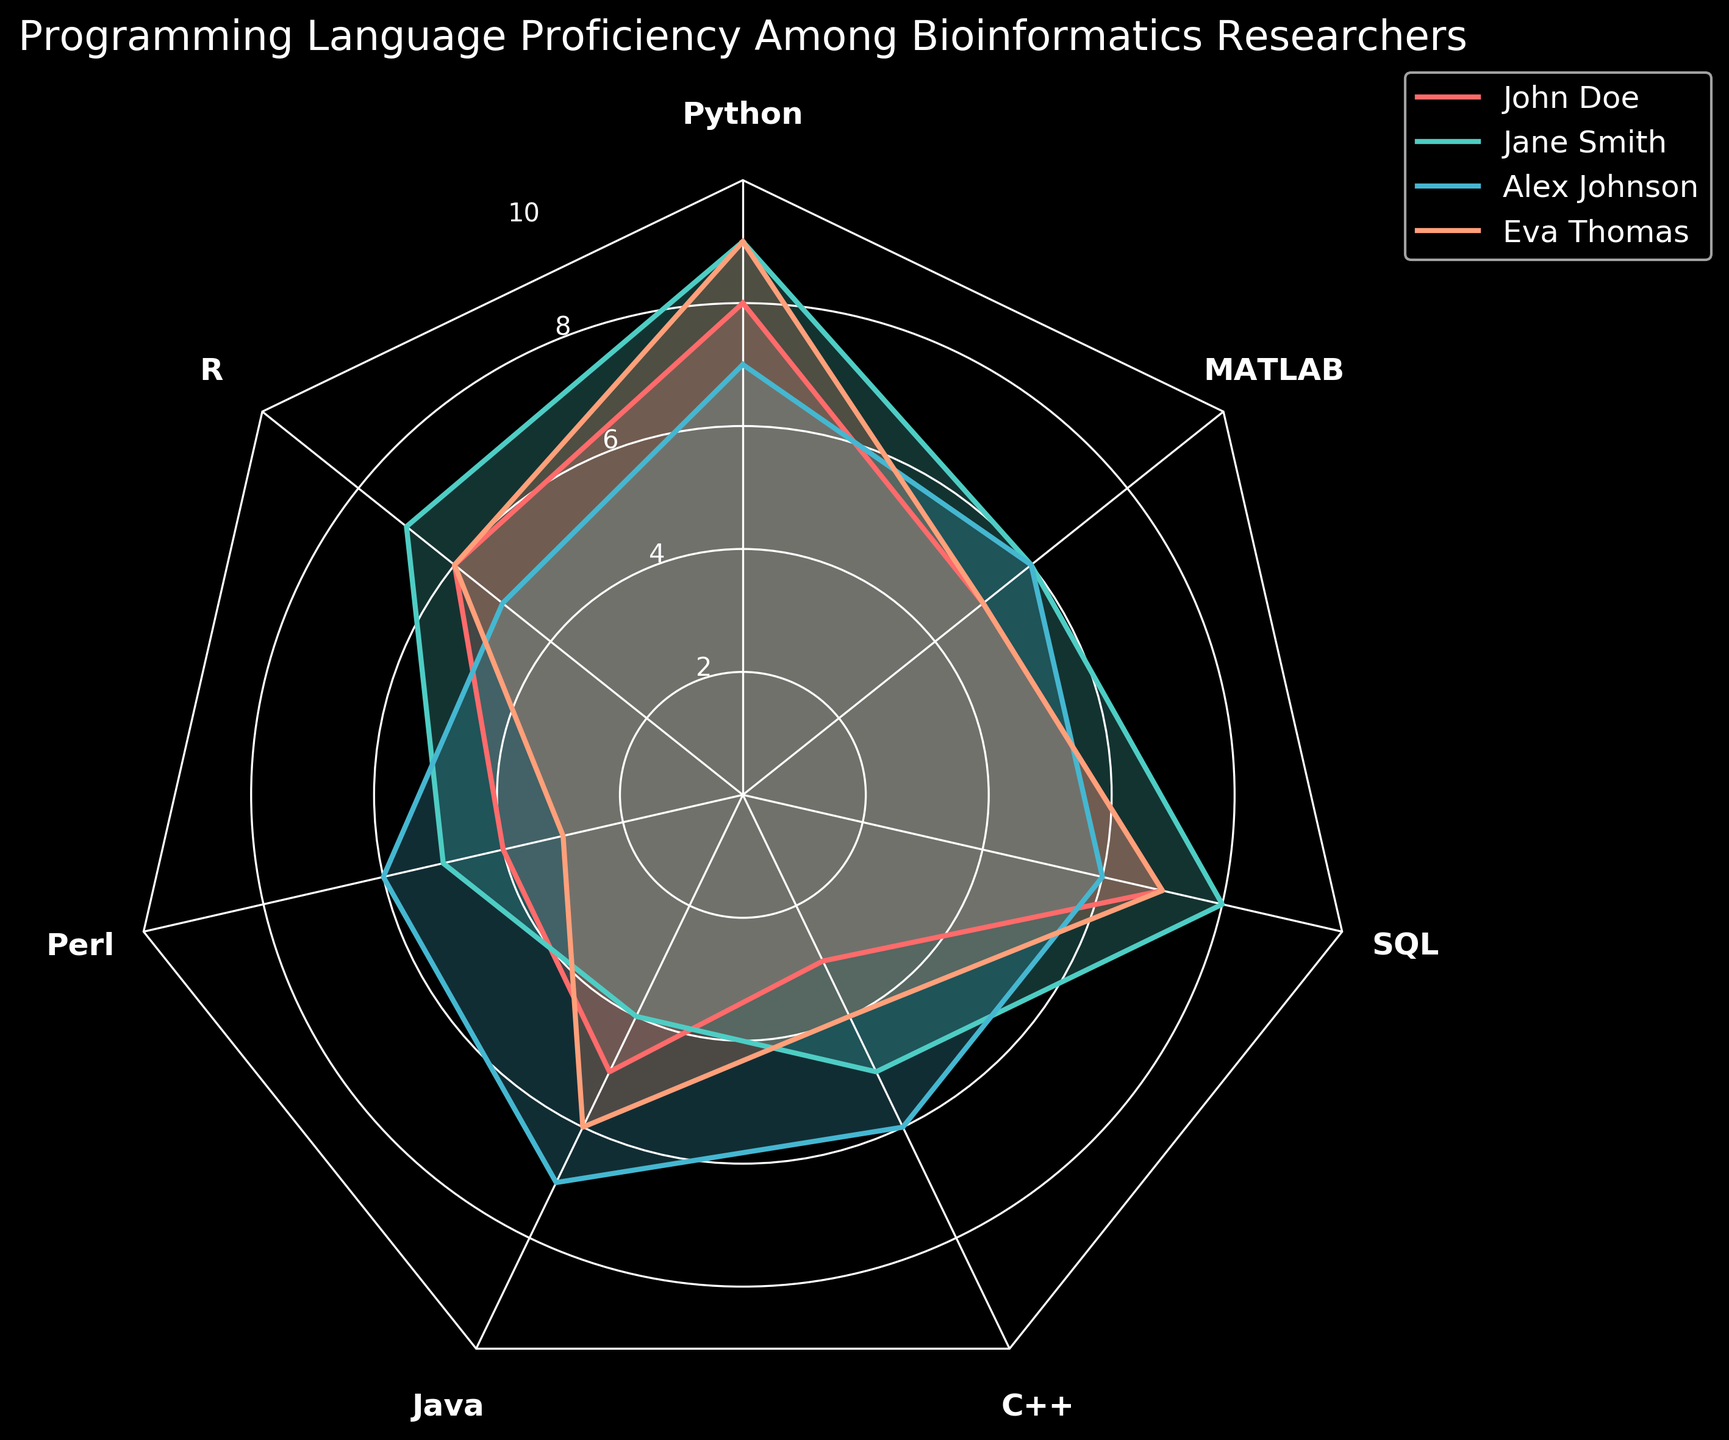What is the title of the radar chart? The title is written at the top of the figure, generally larger and bolder than other texts. It provides an overview of what the chart represents.
Answer: Programming Language Proficiency Among Bioinformatics Researchers Which researcher shows the highest proficiency in Python? Look at the points plotted for Python for each researcher and identify the highest value, which is represented by the most extended line on the radar chart among the values for Python.
Answer: Jane Smith How many programming languages are included in the chart? Count the number of labeled spokes in the radar chart, each representing a different programming language.
Answer: Seven Which programming language does Alex Johnson have the highest proficiency in? Identify the maximum value for Alex Johnson across all programming languages by looking for the most extended plot line for Alex Johnson.
Answer: Java Compare John Doe and Eva Thomas in terms of their proficiency in R. Who has higher proficiency? Check the values plotted for John Doe and Eva Thomas in the R category, identifying which one has a longer line or higher value for R.
Answer: Jane Smith What is the average proficiency score of Eva Thomas across all programming languages? Sum Eva Thomas's values for all programming languages and divide by the number of languages (7): (9 + 6 + 3 + 6 + 4 + 7 + 5) / 7 = 40/7
Answer: 5.7 Which programming language has the lowest proficiency for Jane Smith, and what is the value? Find the minimum value for Jane Smith by locating the shortest plot line associated with her across all language categories.
Answer: Java, 4 Between John Doe and Alex Johnson, who has a higher median proficiency score? Arrange the scores for John Doe and Alex Johnson in ascending order, find the middle value for each, then compare them. For John Doe: [3, 4, 5, 5, 6, 6, 8] -> median is 5. For Alex Johnson: [5, 6, 6, 6, 7, 7, 7] -> median is 6
Answer: Alex Johnson Which researcher exhibits the most balanced proficiency, with the smallest variation across different languages? Evaluate the range of values for each researcher and determine the smallest difference between the highest and lowest scores. For John Doe: range is 8-3=5. For Jane Smith: range is 9-4=5. For Alex Johnson: range is 7-5=2. For Eva Thomas: range is 9-3=6.
Answer: Alex Johnson What is the general trend in proficiency between Python and Perl for all the researchers? Compare the overall pattern of scores for Python to those for Perl for all researchers, noting any significant differences or similarities. For all researchers, Python scores are higher than Perl.
Answer: Higher proficiency in Python 